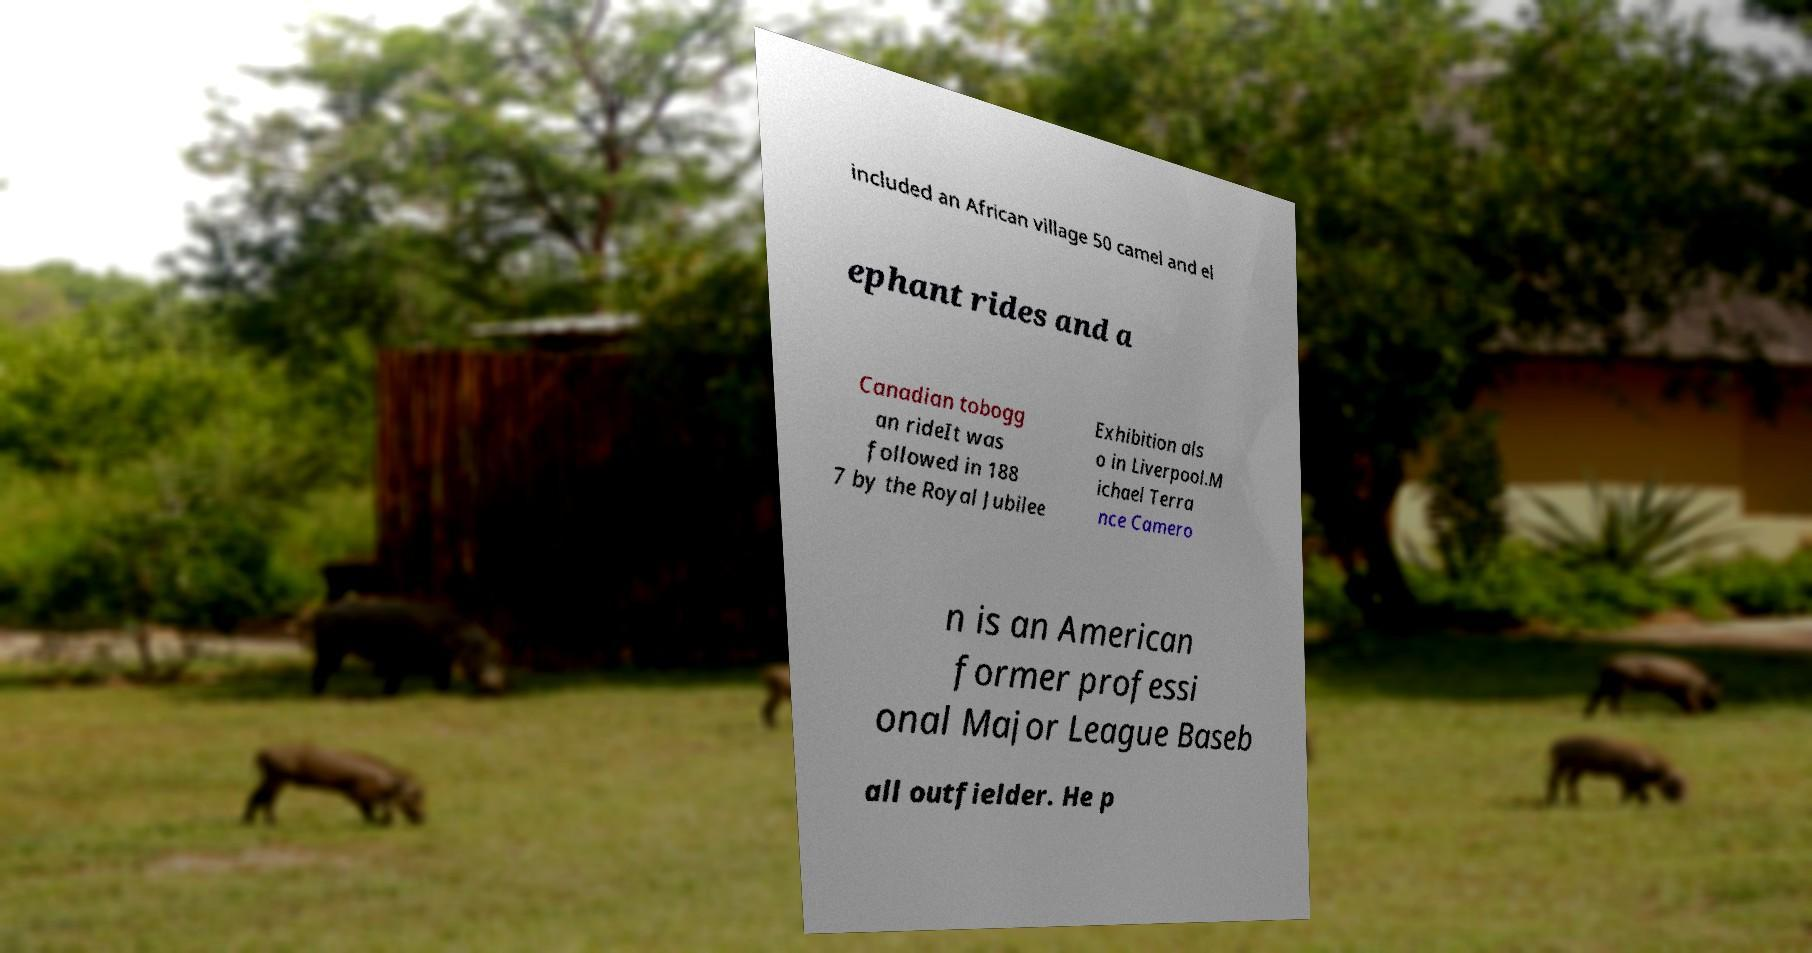Please read and relay the text visible in this image. What does it say? included an African village 50 camel and el ephant rides and a Canadian tobogg an rideIt was followed in 188 7 by the Royal Jubilee Exhibition als o in Liverpool.M ichael Terra nce Camero n is an American former professi onal Major League Baseb all outfielder. He p 